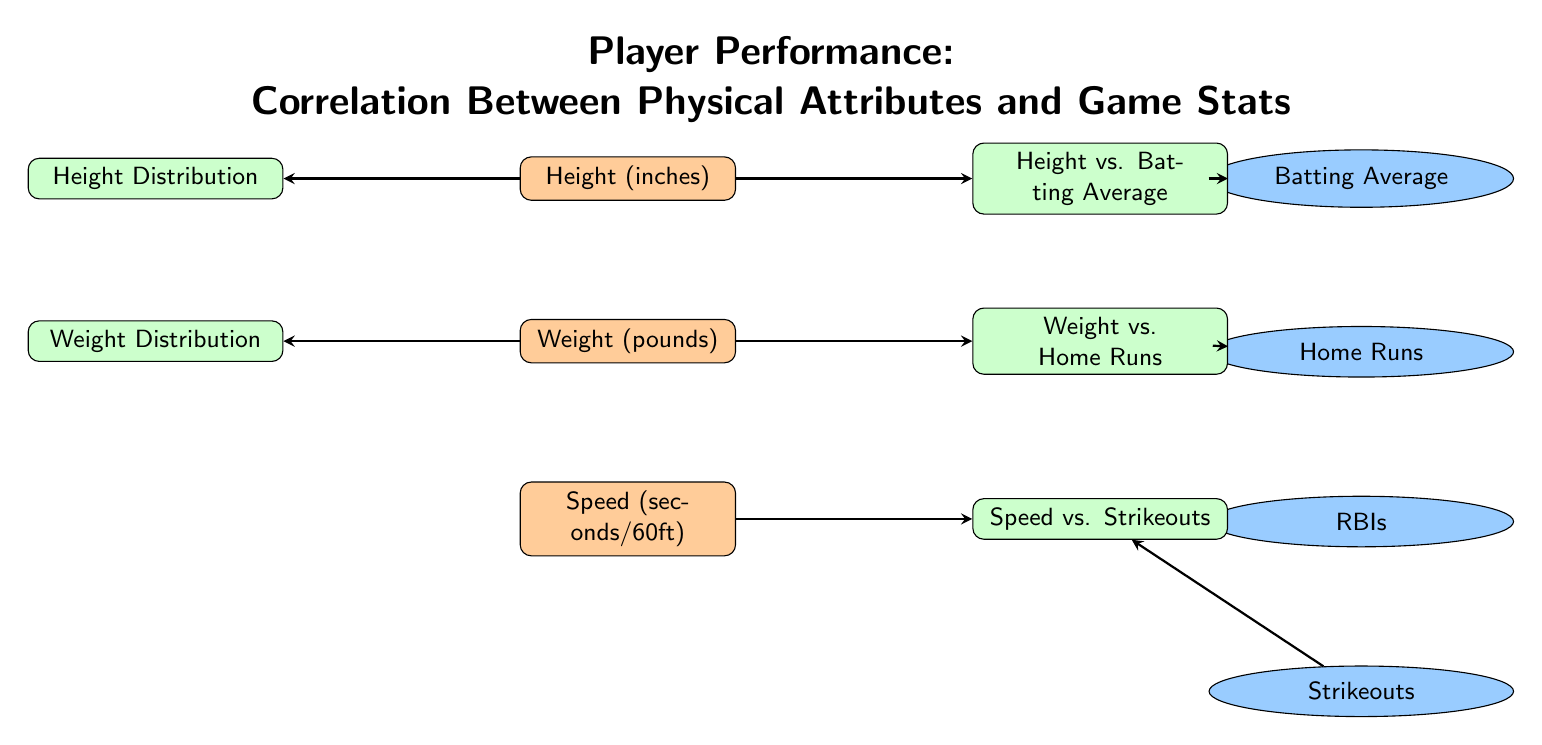What are the three physical attributes represented in the diagram? The diagram includes three physical attributes: Height, Weight, and Speed. These attributes are listed vertically in the left section of the diagram, which shows their relation to various performance metrics.
Answer: Height, Weight, Speed Which performance metric is associated with the scatter plot for height? The scatter plot for height is labeled "Height vs. Batting Average," indicating that it represents the correlation between players' heights and their batting averages. This can be found in the right section of the diagram.
Answer: Batting Average How many performance metrics are depicted in the diagram? There are four performance metrics shown in the diagram: Batting Average, Home Runs, RBIs, and Strikeouts. These are displayed vertically in the right section and are connected to different scatter plots.
Answer: Four What type of plot is used to show the distribution of height? The diagram uses a histogram to represent the distribution of height, advisedly indicated by the node labeled "Height Distribution," which is found on the left side of the height attribute.
Answer: Histogram Which physical attribute is connected to the highest number of performance metrics? The height attribute is connected to the "Batting Average," and it directly leads to the scatter plot "Height vs. Batting Average." It also connects to the histogram "Height Distribution," but does not relate directly to performance metrics beyond the scatter plot. Thus, it has the same number of connections as weight.
Answer: Height (or Weight) What relationship does the diagram suggest between speed and strikeouts? The diagram indicates a relationship between speed and strikeouts through the scatter plot labeled "Speed vs. Strikeouts," meaning that the plot illustrates how players' speed may correlate with the number of strikeouts they achieve.
Answer: Correlation How many scatter plots are present in the diagram? There are three scatter plots illustrated in the diagram. Each one corresponds to a different combination of a physical attribute and a performance metric, such as Height vs. Batting Average, Weight vs. Home Runs, and Speed vs. Strikeouts.
Answer: Three What is the color used for the performance metrics in the diagram? The performance metrics are represented in a light blue color, referred to in the diagram as performanceColor. This can be noted by examining the fill color of the nodes that contain the performance metrics.
Answer: Light blue 